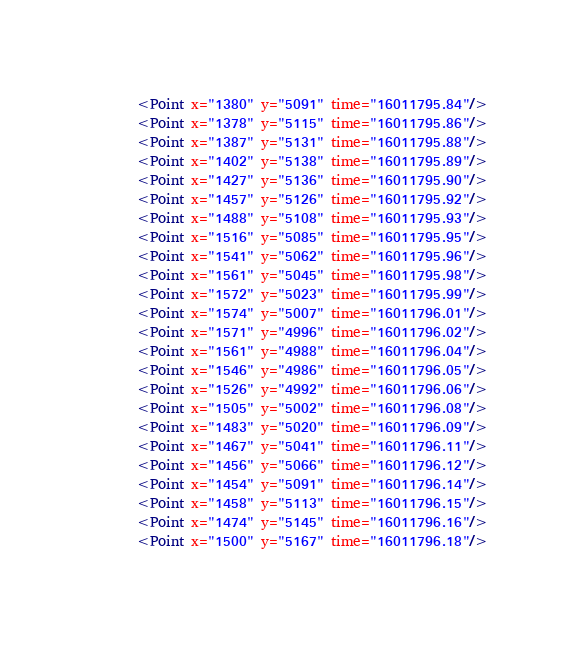<code> <loc_0><loc_0><loc_500><loc_500><_XML_>      <Point x="1380" y="5091" time="16011795.84"/>
      <Point x="1378" y="5115" time="16011795.86"/>
      <Point x="1387" y="5131" time="16011795.88"/>
      <Point x="1402" y="5138" time="16011795.89"/>
      <Point x="1427" y="5136" time="16011795.90"/>
      <Point x="1457" y="5126" time="16011795.92"/>
      <Point x="1488" y="5108" time="16011795.93"/>
      <Point x="1516" y="5085" time="16011795.95"/>
      <Point x="1541" y="5062" time="16011795.96"/>
      <Point x="1561" y="5045" time="16011795.98"/>
      <Point x="1572" y="5023" time="16011795.99"/>
      <Point x="1574" y="5007" time="16011796.01"/>
      <Point x="1571" y="4996" time="16011796.02"/>
      <Point x="1561" y="4988" time="16011796.04"/>
      <Point x="1546" y="4986" time="16011796.05"/>
      <Point x="1526" y="4992" time="16011796.06"/>
      <Point x="1505" y="5002" time="16011796.08"/>
      <Point x="1483" y="5020" time="16011796.09"/>
      <Point x="1467" y="5041" time="16011796.11"/>
      <Point x="1456" y="5066" time="16011796.12"/>
      <Point x="1454" y="5091" time="16011796.14"/>
      <Point x="1458" y="5113" time="16011796.15"/>
      <Point x="1474" y="5145" time="16011796.16"/>
      <Point x="1500" y="5167" time="16011796.18"/></code> 